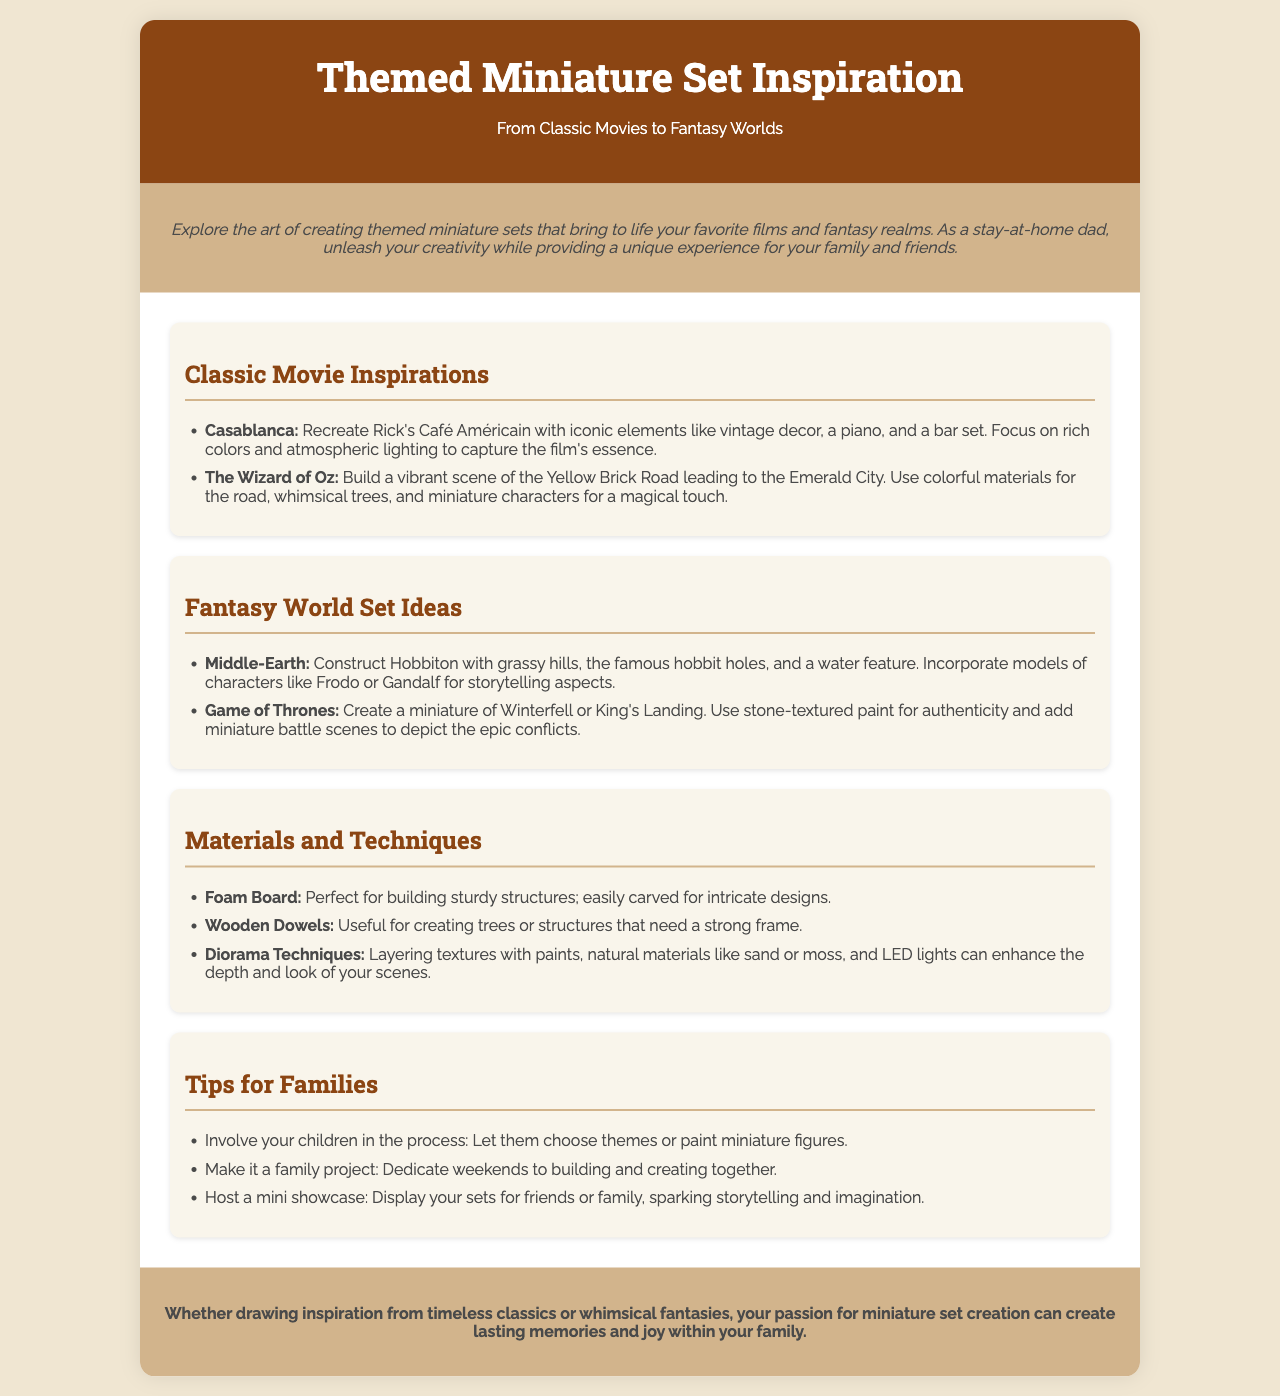What are two classic movie inspirations mentioned? The document lists "Casablanca" and "The Wizard of Oz" as classic movie inspirations in the section dedicated to them.
Answer: Casablanca, The Wizard of Oz What is a fantasy world set idea? The document mentions "Middle-Earth" and "Game of Thrones" as fantasy world set ideas in the respective section.
Answer: Middle-Earth, Game of Thrones What material is perfect for building sturdy structures? The document states that "Foam Board" is perfect for creating sturdy structures without any mention of other materials.
Answer: Foam Board How many tips for families are provided? The document enumerates three tips for families in the designated section, indicating the number of suggestions offered.
Answer: Three What can be enhanced with diorama techniques according to the document? The document mentions that layering textures with paints and other elements can enhance the depth and look of your scenes, referring to diorama techniques.
Answer: Depth and look Which classic movie is associated with a piano and bar set? The description for "Casablanca" includes elements like a piano and bar set, specifically mentioned in that section.
Answer: Casablanca What character models can be incorporated in the Middle-Earth set? The document suggests incorporating models of characters like "Frodo" or "Gandalf" in the Middle-Earth set for storytelling.
Answer: Frodo, Gandalf What theme is suggested for a family project? The document states that making it a family project and dedicating weekends to building is suggested as part of the tips for families.
Answer: Family project 